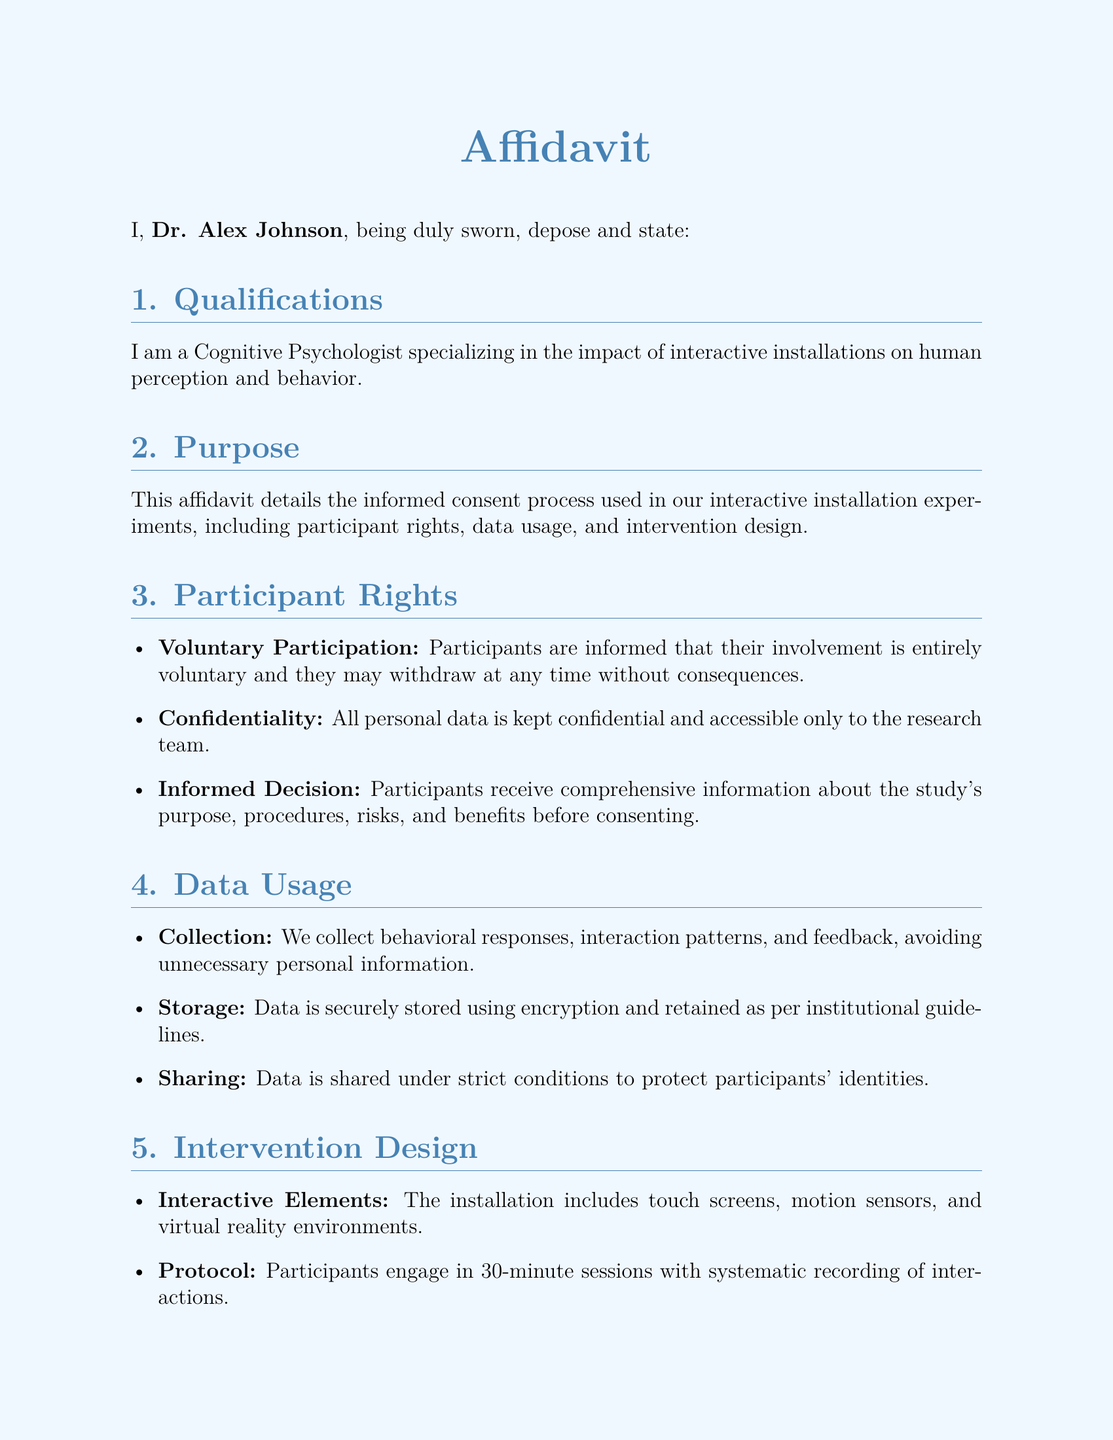What is the name of the affiant? The affiant is the individual making the affidavit, which in this case is Dr. Alex Johnson.
Answer: Dr. Alex Johnson What is the date of the affidavit? The date when the affidavit was signed and affirmed is specified as October 10, 2023.
Answer: October 10, 2023 How long are the interactive sessions? The document states that participants engage in 30-minute sessions during the intervention.
Answer: 30-minute What ethical guidelines does the intervention adhere to? The ethical framework followed is mentioned as the APA ethical guidelines, which outline the principles for ethical research.
Answer: APA ethical guidelines What types of data are collected during the experiments? The data includes behavioral responses, interaction patterns, and feedback from the participants, without unnecessary personal information.
Answer: Behavioral responses, interaction patterns, and feedback Are participants allowed to withdraw from the study? The informed consent process stipulates that participants can withdraw at any time without facing any consequences.
Answer: Yes What does the intervention design include? The installation features interactive elements such as touch screens, motion sensors, and virtual reality environments.
Answer: Touch screens, motion sensors, and virtual reality environments Who has access to the personal data collected? According to the affidavit, personal data is kept confidential and is only accessible to the research team.
Answer: Research team What kind of sessions are included in the intervention protocol? The sessions are systematically recorded during participant interactions, focusing on their engagement with the installation.
Answer: Systematic recording of interactions 